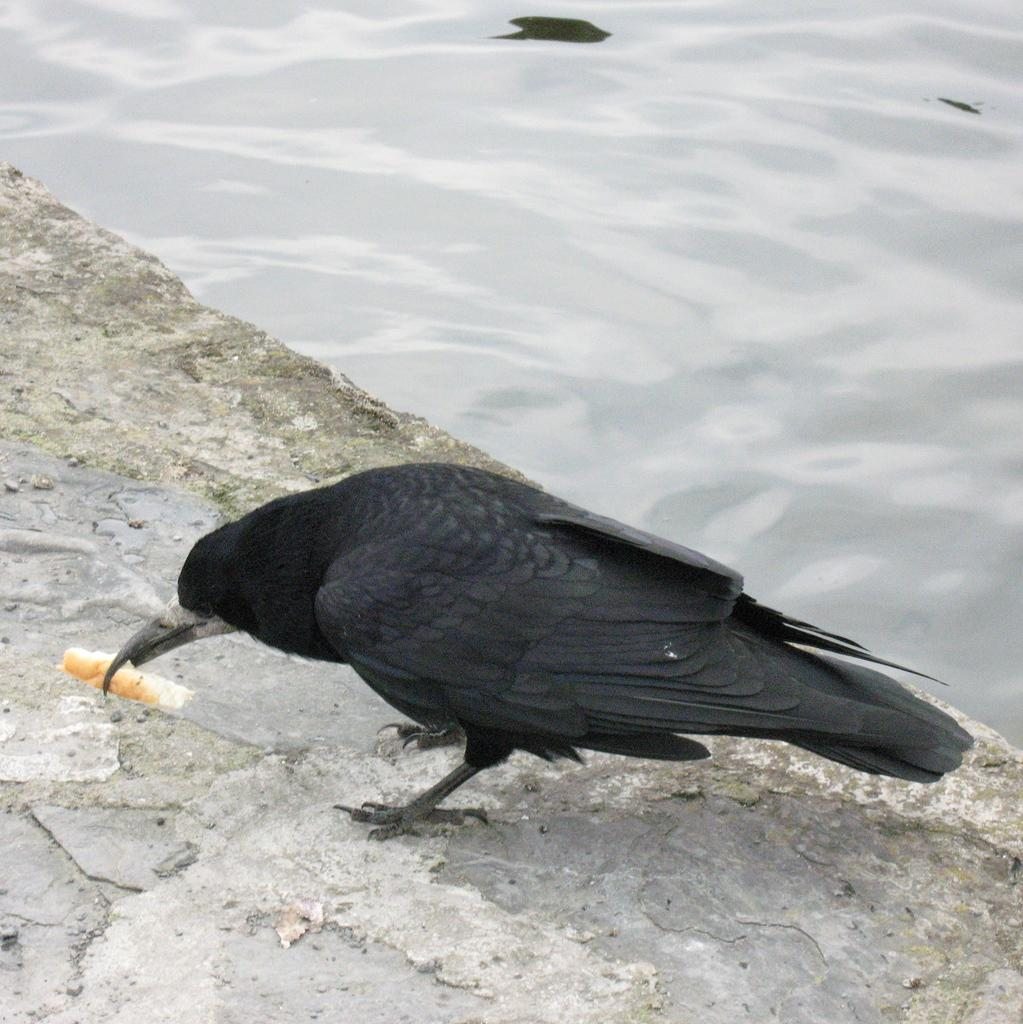What type of bird is in the image? There is a crow in the image. Where is the crow located in the image? The crow is standing on the floor. What is the crow holding in its beak? The crow is holding a food piece in its beak. What can be seen at the top of the image? There is water visible at the top of the image. What note is the crow playing on the piano in the image? There is no piano or note-playing activity present in the image; it features a crow standing on the floor holding a food piece. 